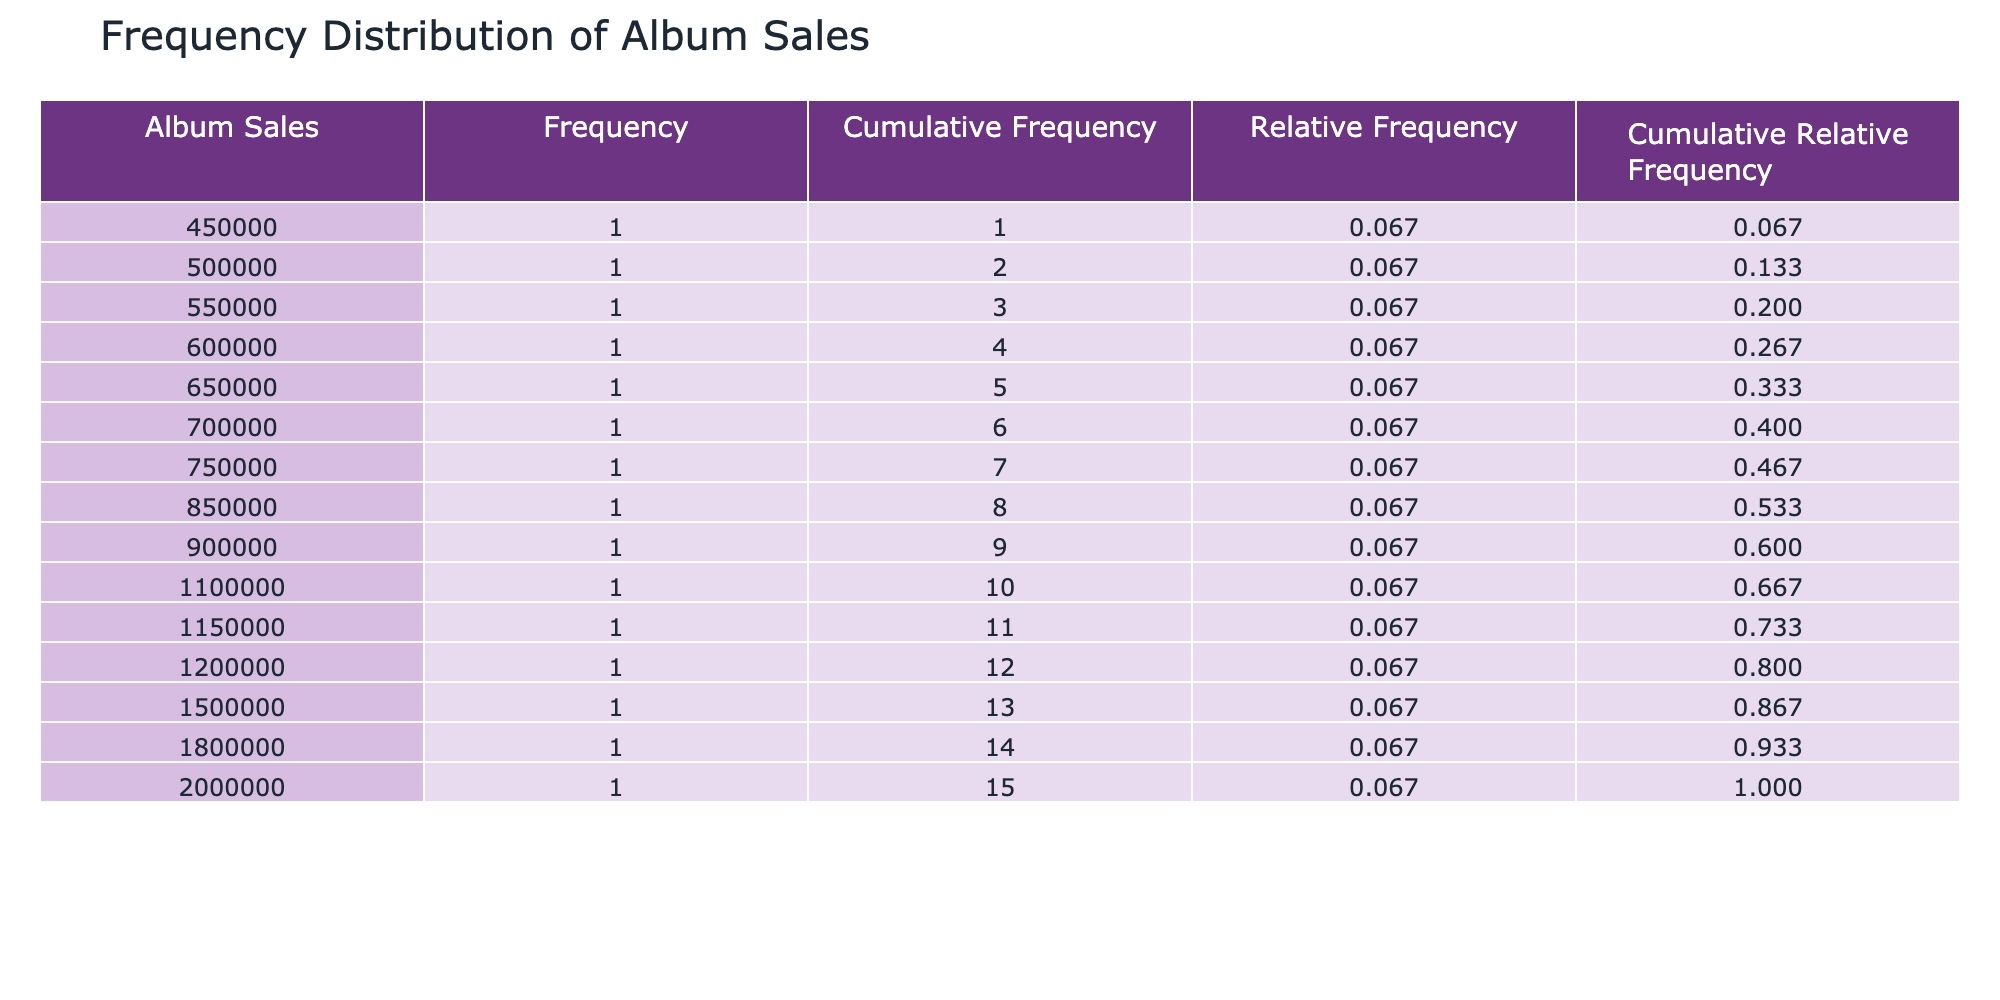What is the total number of album sales for the top three artists? The top three artists are Taylor Swift, Drake, and Beyoncé with album sales of 2,000,000, 1,800,000, and 1,500,000, respectively. Adding these values gives: 2,000,000 + 1,800,000 + 1,500,000 = 5,300,000.
Answer: 5,300,000 How many artists have album sales greater than 1,000,000? To find this, we can count the artists in the table with album sales exceeding 1,000,000. The artists with such sales are Taylor Swift, Drake, Beyoncé, Adele, Ed Sheeran, and Bruno Mars, totaling 6 artists.
Answer: 6 What is the cumulative frequency of album sales above 500,000? First, identify the artists with album sales above 500,000 from the table, then sum the frequency values for these ranges accordingly. There are 12 artists with album sales greater than 500,000, giving a cumulative frequency of 12.
Answer: 12 Is Drake ranked higher than Adele based on album sales? Drake is ranked 2nd with album sales of 1,800,000, while Adele is ranked 5th with album sales of 1,150,000. Since 2 is less than 5, Drake has a higher rank than Adele.
Answer: Yes What is the average album sales for the artists ranked from 6 to 10? The artists ranked 6 to 10 are Ed Sheeran, Bruno Mars, Katy Perry, Lady Gaga, and Maroon 5 with sales of 1,100,000, 900,000, 850,000, 750,000, and 700,000 respectively. To find the average, sum these values: 1,100,000 + 900,000 + 850,000 + 750,000 + 700,000 = 4,300,000. There are 5 artists, so the average is 4,300,000 / 5 = 860,000.
Answer: 860,000 How much difference is there in album sales between the top artist and the artist ranked 15th? The top artist is Taylor Swift with album sales of 2,000,000, while the 15th-ranked artist, Oasis, has album sales of 450,000. The difference is calculated as 2,000,000 - 450,000 = 1,550,000.
Answer: 1,550,000 Are there more artists with album sales below 1,000,000 than those with sales above? Counting artists with sales below 1,000,000 gives us 5 (Bruno Mars, Katy Perry, Lady Gaga, Maroon 5, Billie Eilish, Sam Smith, Justin Bieber, Coldplay, Oasis), while sales above 1,000,000 have 10 (Taylor Swift, Drake, Beyoncé, Adele, Ed Sheeran). Since 10 is more than 5, the statement is false.
Answer: No 